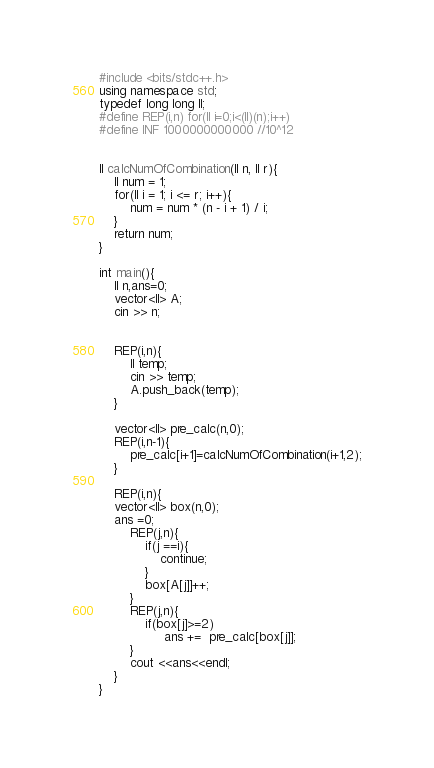Convert code to text. <code><loc_0><loc_0><loc_500><loc_500><_C++_>#include <bits/stdc++.h>
using namespace std;
typedef long long ll;
#define REP(i,n) for(ll i=0;i<(ll)(n);i++)
#define INF 1000000000000 //10^12


ll calcNumOfCombination(ll n, ll r){
    ll num = 1;
    for(ll i = 1; i <= r; i++){
        num = num * (n - i + 1) / i;
    }
    return num;
}

int main(){
    ll n,ans=0;
    vector<ll> A;
    cin >> n;


    REP(i,n){
        ll temp;
        cin >> temp;
        A.push_back(temp);
    }
    
    vector<ll> pre_calc(n,0);
    REP(i,n-1){
        pre_calc[i+1]=calcNumOfCombination(i+1,2);
    }

    REP(i,n){
    vector<ll> box(n,0);
    ans =0;
        REP(j,n){
            if(j ==i){
                continue;
            }
            box[A[j]]++;
        }
        REP(j,n){
            if(box[j]>=2)
                 ans +=  pre_calc[box[j]];
        }
        cout <<ans<<endl;
    }
}

</code> 